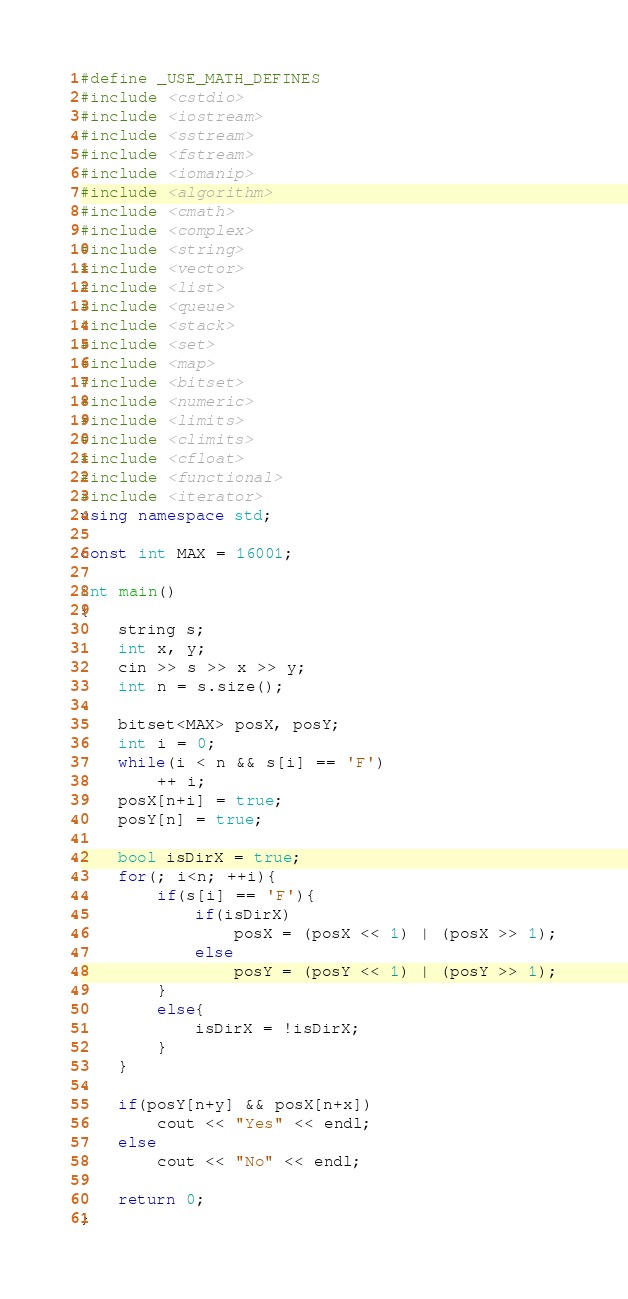Convert code to text. <code><loc_0><loc_0><loc_500><loc_500><_C++_>#define _USE_MATH_DEFINES
#include <cstdio>
#include <iostream>
#include <sstream>
#include <fstream>
#include <iomanip>
#include <algorithm>
#include <cmath>
#include <complex>
#include <string>
#include <vector>
#include <list>
#include <queue>
#include <stack>
#include <set>
#include <map>
#include <bitset>
#include <numeric>
#include <limits>
#include <climits>
#include <cfloat>
#include <functional>
#include <iterator>
using namespace std;

const int MAX = 16001;

int main()
{
    string s;
    int x, y;
    cin >> s >> x >> y;
    int n = s.size();

    bitset<MAX> posX, posY;
    int i = 0;
    while(i < n && s[i] == 'F')
        ++ i;
    posX[n+i] = true;
    posY[n] = true;

    bool isDirX = true;
    for(; i<n; ++i){
        if(s[i] == 'F'){
            if(isDirX)
                posX = (posX << 1) | (posX >> 1);
            else
                posY = (posY << 1) | (posY >> 1);
        }
        else{
            isDirX = !isDirX;
        }
    }

    if(posY[n+y] && posX[n+x])
        cout << "Yes" << endl;
    else
        cout << "No" << endl;

    return 0;
}
</code> 